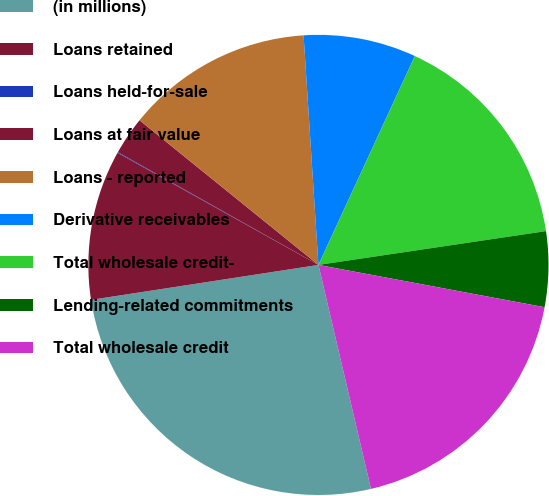Convert chart. <chart><loc_0><loc_0><loc_500><loc_500><pie_chart><fcel>(in millions)<fcel>Loans retained<fcel>Loans held-for-sale<fcel>Loans at fair value<fcel>Loans - reported<fcel>Derivative receivables<fcel>Total wholesale credit-<fcel>Lending-related commitments<fcel>Total wholesale credit<nl><fcel>26.24%<fcel>10.53%<fcel>0.05%<fcel>2.67%<fcel>13.15%<fcel>7.91%<fcel>15.77%<fcel>5.29%<fcel>18.39%<nl></chart> 